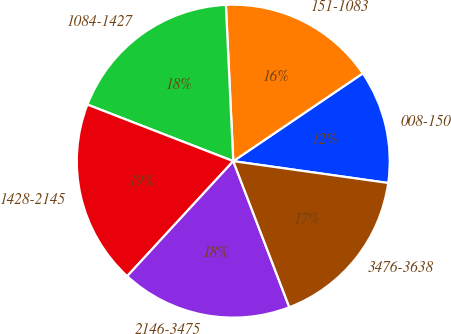<chart> <loc_0><loc_0><loc_500><loc_500><pie_chart><fcel>008-150<fcel>151-1083<fcel>1084-1427<fcel>1428-2145<fcel>2146-3475<fcel>3476-3638<nl><fcel>11.71%<fcel>16.27%<fcel>18.36%<fcel>19.03%<fcel>17.69%<fcel>16.94%<nl></chart> 